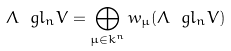Convert formula to latex. <formula><loc_0><loc_0><loc_500><loc_500>\Lambda \ g l _ { n } V = \bigoplus _ { \mu \in k ^ { n } } w _ { \mu } ( \Lambda \ g l _ { n } V )</formula> 